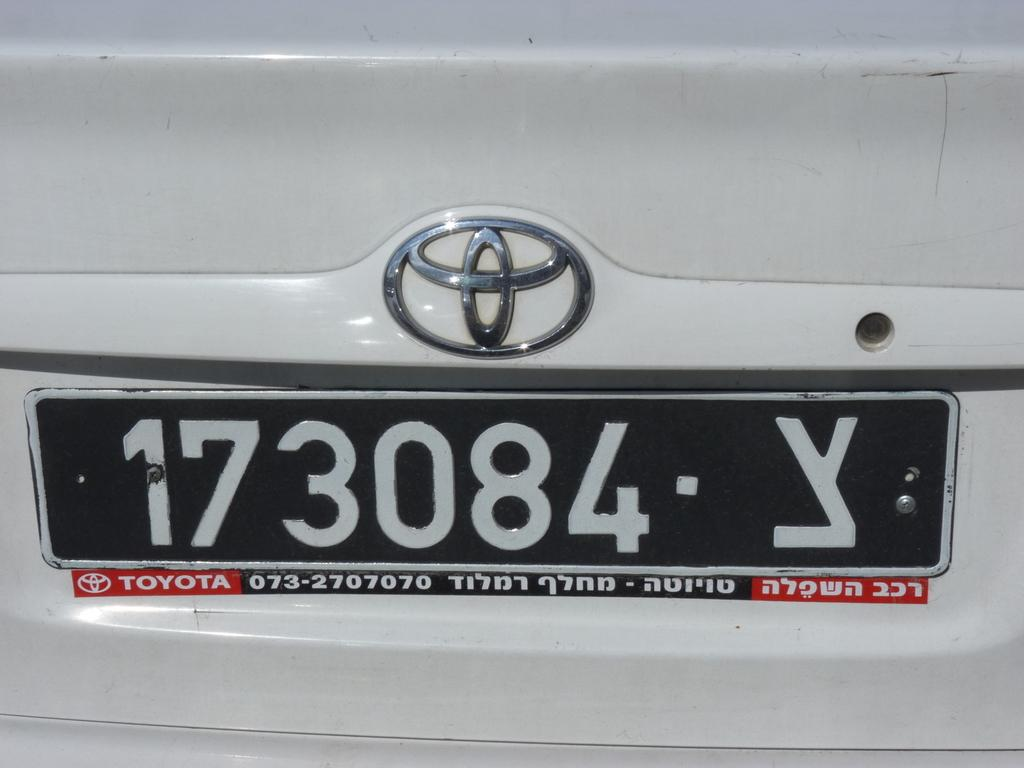<image>
Give a short and clear explanation of the subsequent image. A license plate on a car shows the Toyota brand beneath it. 